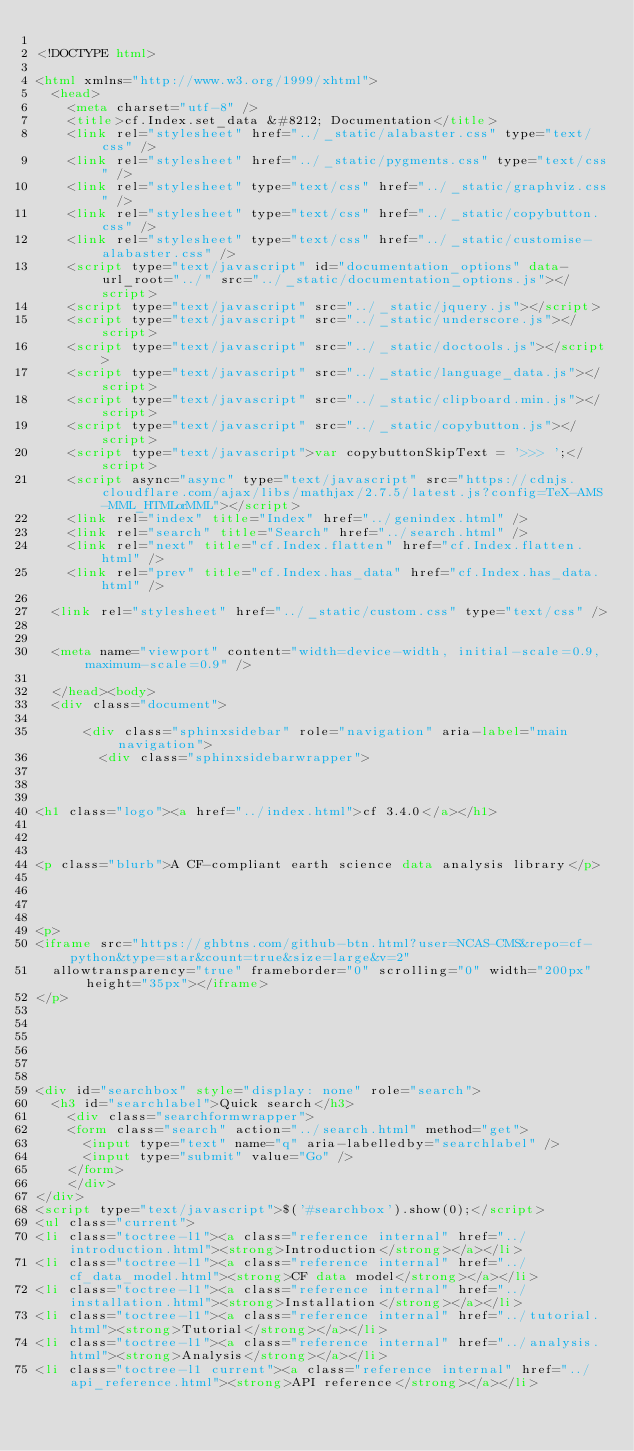Convert code to text. <code><loc_0><loc_0><loc_500><loc_500><_HTML_>
<!DOCTYPE html>

<html xmlns="http://www.w3.org/1999/xhtml">
  <head>
    <meta charset="utf-8" />
    <title>cf.Index.set_data &#8212; Documentation</title>
    <link rel="stylesheet" href="../_static/alabaster.css" type="text/css" />
    <link rel="stylesheet" href="../_static/pygments.css" type="text/css" />
    <link rel="stylesheet" type="text/css" href="../_static/graphviz.css" />
    <link rel="stylesheet" type="text/css" href="../_static/copybutton.css" />
    <link rel="stylesheet" type="text/css" href="../_static/customise-alabaster.css" />
    <script type="text/javascript" id="documentation_options" data-url_root="../" src="../_static/documentation_options.js"></script>
    <script type="text/javascript" src="../_static/jquery.js"></script>
    <script type="text/javascript" src="../_static/underscore.js"></script>
    <script type="text/javascript" src="../_static/doctools.js"></script>
    <script type="text/javascript" src="../_static/language_data.js"></script>
    <script type="text/javascript" src="../_static/clipboard.min.js"></script>
    <script type="text/javascript" src="../_static/copybutton.js"></script>
    <script type="text/javascript">var copybuttonSkipText = '>>> ';</script>
    <script async="async" type="text/javascript" src="https://cdnjs.cloudflare.com/ajax/libs/mathjax/2.7.5/latest.js?config=TeX-AMS-MML_HTMLorMML"></script>
    <link rel="index" title="Index" href="../genindex.html" />
    <link rel="search" title="Search" href="../search.html" />
    <link rel="next" title="cf.Index.flatten" href="cf.Index.flatten.html" />
    <link rel="prev" title="cf.Index.has_data" href="cf.Index.has_data.html" />
   
  <link rel="stylesheet" href="../_static/custom.css" type="text/css" />
  
  
  <meta name="viewport" content="width=device-width, initial-scale=0.9, maximum-scale=0.9" />

  </head><body>
  <div class="document">
    
      <div class="sphinxsidebar" role="navigation" aria-label="main navigation">
        <div class="sphinxsidebarwrapper">



<h1 class="logo"><a href="../index.html">cf 3.4.0</a></h1>



<p class="blurb">A CF-compliant earth science data analysis library</p>




<p>
<iframe src="https://ghbtns.com/github-btn.html?user=NCAS-CMS&repo=cf-python&type=star&count=true&size=large&v=2"
  allowtransparency="true" frameborder="0" scrolling="0" width="200px" height="35px"></iframe>
</p>






<div id="searchbox" style="display: none" role="search">
  <h3 id="searchlabel">Quick search</h3>
    <div class="searchformwrapper">
    <form class="search" action="../search.html" method="get">
      <input type="text" name="q" aria-labelledby="searchlabel" />
      <input type="submit" value="Go" />
    </form>
    </div>
</div>
<script type="text/javascript">$('#searchbox').show(0);</script>
<ul class="current">
<li class="toctree-l1"><a class="reference internal" href="../introduction.html"><strong>Introduction</strong></a></li>
<li class="toctree-l1"><a class="reference internal" href="../cf_data_model.html"><strong>CF data model</strong></a></li>
<li class="toctree-l1"><a class="reference internal" href="../installation.html"><strong>Installation</strong></a></li>
<li class="toctree-l1"><a class="reference internal" href="../tutorial.html"><strong>Tutorial</strong></a></li>
<li class="toctree-l1"><a class="reference internal" href="../analysis.html"><strong>Analysis</strong></a></li>
<li class="toctree-l1 current"><a class="reference internal" href="../api_reference.html"><strong>API reference</strong></a></li></code> 